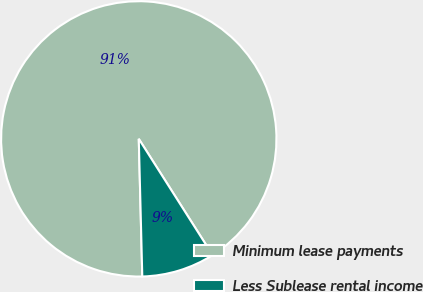Convert chart. <chart><loc_0><loc_0><loc_500><loc_500><pie_chart><fcel>Minimum lease payments<fcel>Less Sublease rental income<nl><fcel>91.4%<fcel>8.6%<nl></chart> 